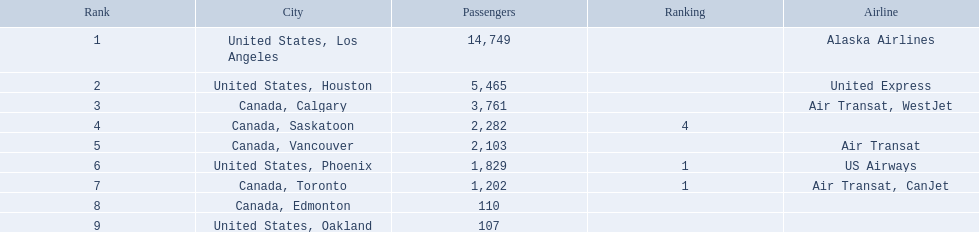What locations does the airport serve? United States, Los Angeles, United States, Houston, Canada, Calgary, Canada, Saskatoon, Canada, Vancouver, United States, Phoenix, Canada, Toronto, Canada, Edmonton, United States, Oakland. What is the passenger count for phoenix? 1,829. Which airport has the minimum passenger volume? 107. What airport contains 107 passengers? United States, Oakland. Which cities are connected to playa de oro international airport? United States, Los Angeles, United States, Houston, Canada, Calgary, Canada, Saskatoon, Canada, Vancouver, United States, Phoenix, Canada, Toronto, Canada, Edmonton, United States, Oakland. What is the passenger count for los angeles, united states? 14,749. Which other cities, when combined with los angeles, would have an approximate passenger count of 19,000? Canada, Calgary. Which destinations do the aircraft travel to? United States, Los Angeles, United States, Houston, Canada, Calgary, Canada, Saskatoon, Canada, Vancouver, United States, Phoenix, Canada, Toronto, Canada, Edmonton, United States, Oakland. What is the number of passengers heading to phoenix, arizona? 1,829. 